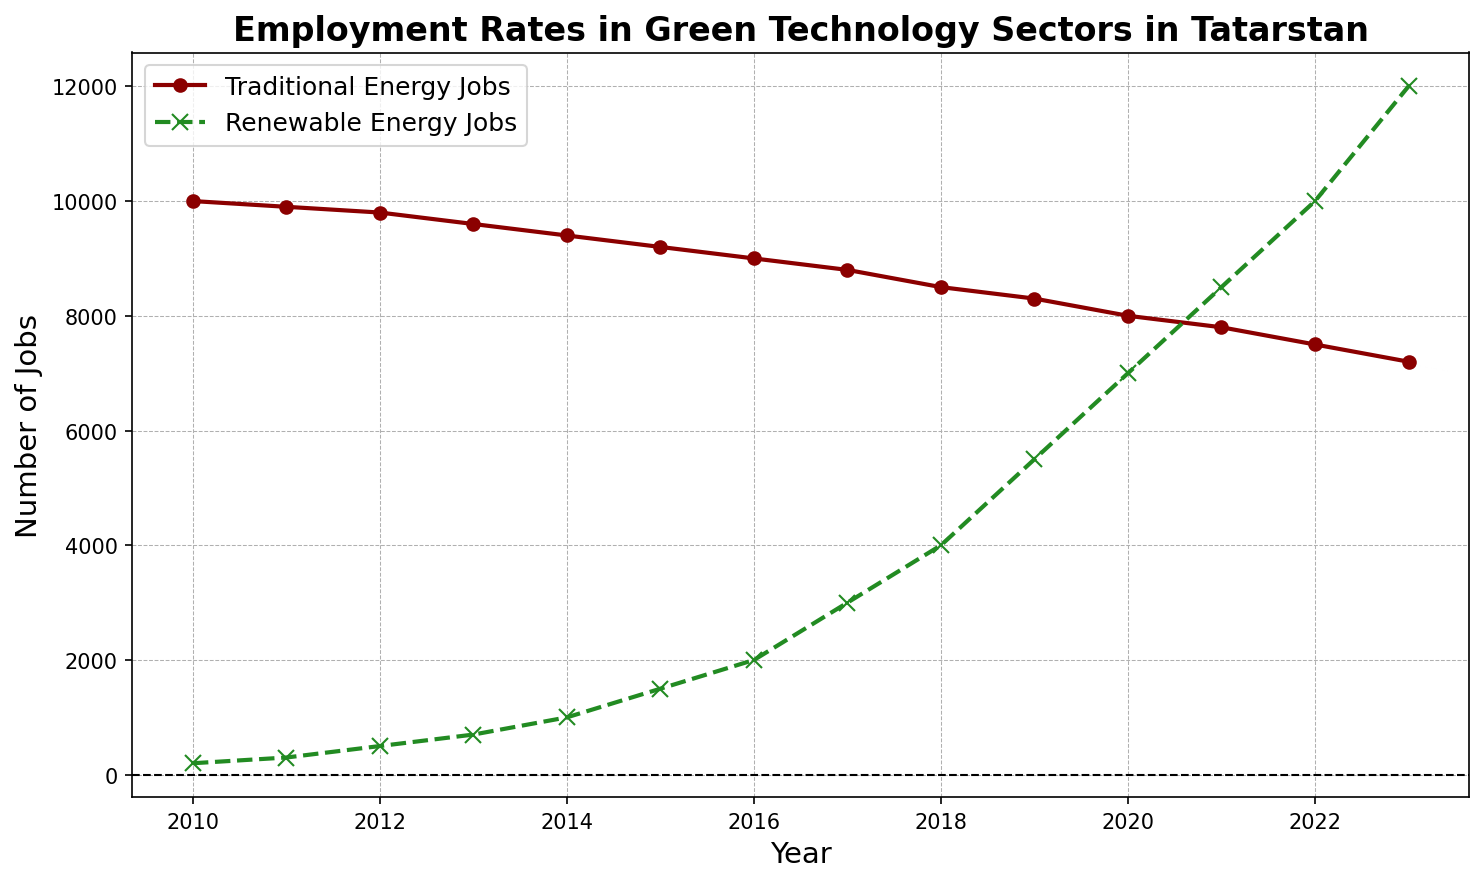What general trend do you observe for traditional energy jobs from 2010 to 2023? The plot shows that the number of traditional energy jobs decreases consistently from 10,000 in 2010 to 7,200 in 2023, indicating a downward trend.
Answer: Downward trend How do the employment rates in renewable energy jobs change from 2010 to 2023? The plot shows a significant increase in renewable energy jobs from 200 in 2010 to 12,000 in 2023, indicating rapid growth.
Answer: Rapid growth When does the number of renewable energy jobs surpass the number of traditional energy jobs? By observing the intersection of the two lines, it is clear that in 2022, the number of renewable energy jobs (10,000) surpasses traditional energy jobs (7,500).
Answer: 2022 What is the difference in the number of renewable energy jobs between 2012 and 2018? In 2012, the number of renewable energy jobs is 500, and in 2018, it is 4,000. The difference is 4,000 - 500 = 3,500.
Answer: 3,500 What year has the smallest number of traditional energy jobs, and what is that number? By looking at the declining trend of the traditional energy jobs line, the smallest number is observed in 2023, with a value of 7,200.
Answer: 2023, 7,200 Compare the number of traditional energy jobs and renewable energy jobs in 2015. Which sector had more jobs, and by how much? In 2015, the number of traditional energy jobs is 9,200, and renewable energy jobs is 1,500. The traditional energy sector has more jobs by 9,200 - 1,500 = 7,700.
Answer: Traditional energy jobs, 7,700 What is the average number of renewable energy jobs from 2010 to 2023? Sum the renewable energy jobs for each year from 2010 to 2023 and divide by the number of years (14 years). The sum is 200 + 300 + 500 + 700 + 1,000 + 1,500 + 2,000 + 3,000 + 4,000 + 5,500 + 7,000 + 8,500 + 10,000 + 12,000 = 55,200. So the average is 55,200 / 14 ≈ 3,943.
Answer: ≈ 3,943 What is the highest number of renewable energy jobs reached, and in which year did this occur? The highest point of the green (renewable energy jobs) line is at 12,000, which occurs in 2023.
Answer: 12,000, 2023 From the plot, which year experienced the highest increase in renewable energy jobs compared to the previous year, and what is the increase? By observing the steepness between the points of the renewable energy jobs line, the highest increase is between 2022 and 2023, where jobs increased from 10,000 to 12,000. The increase is 12,000 - 10,000 = 2,000.
Answer: 2022 to 2023, 2,000 